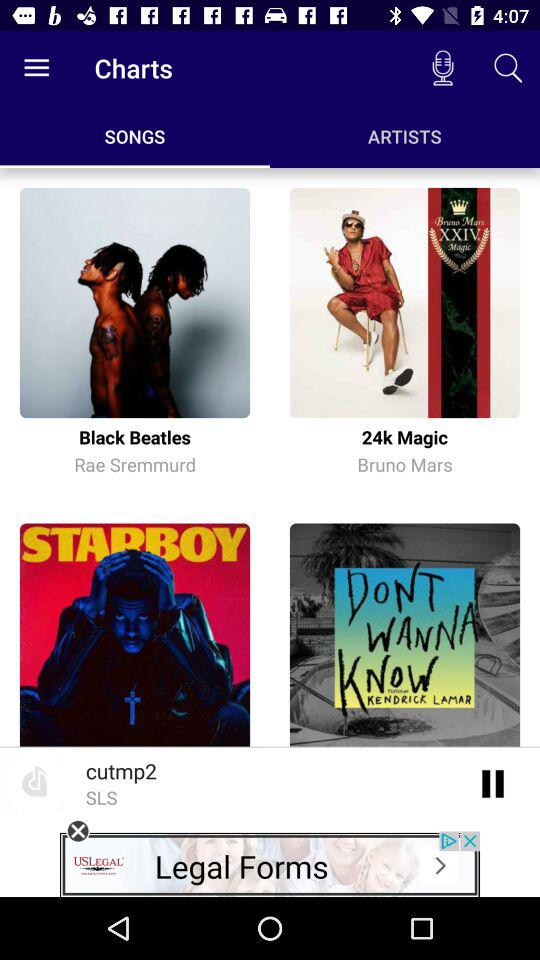What song is currently playing? The song currently playing is "cutmp2". 